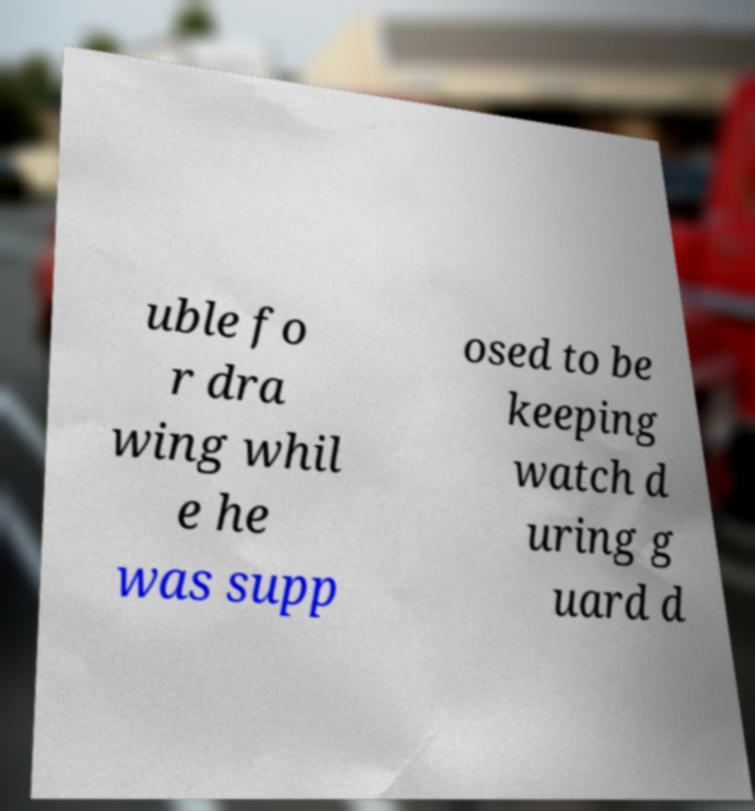Can you accurately transcribe the text from the provided image for me? uble fo r dra wing whil e he was supp osed to be keeping watch d uring g uard d 